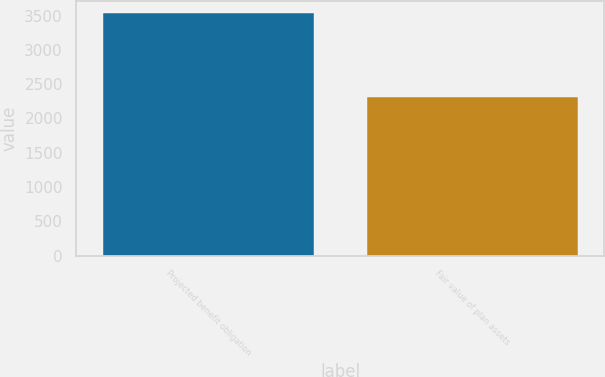Convert chart to OTSL. <chart><loc_0><loc_0><loc_500><loc_500><bar_chart><fcel>Projected benefit obligation<fcel>Fair value of plan assets<nl><fcel>3540<fcel>2314<nl></chart> 